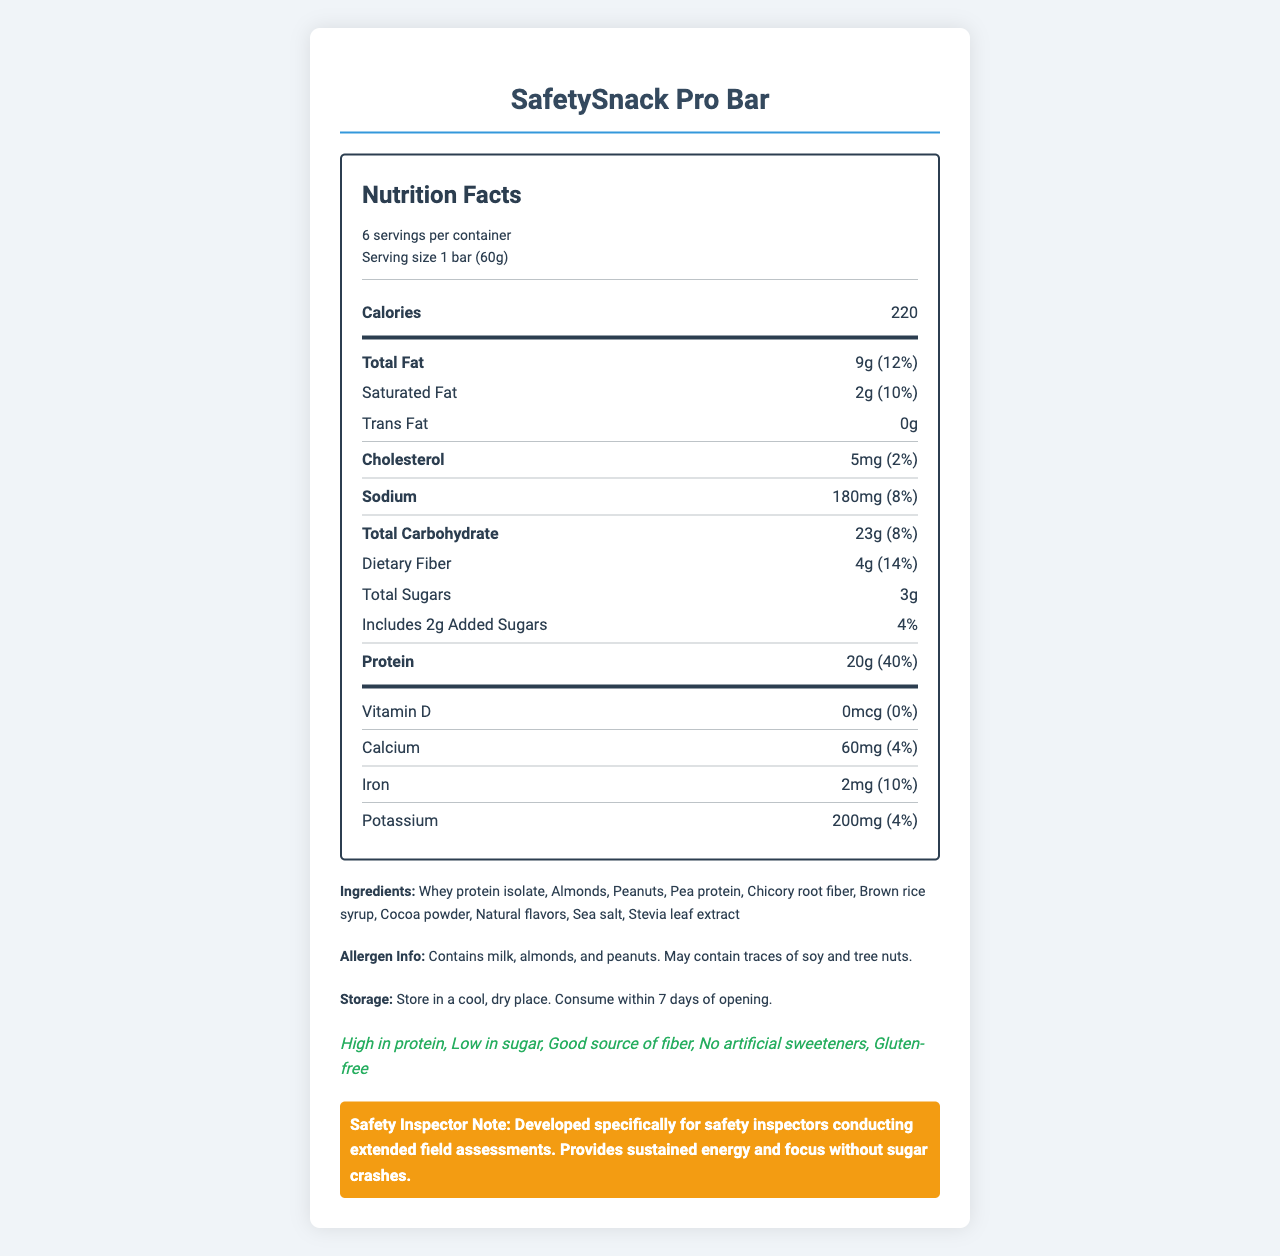what is the serving size of the SafetySnack Pro Bar? The document specifies the serving size in the serving information section as "1 bar (60g)".
Answer: 1 bar (60g) How many calories are in one serving of the SafetySnack Pro Bar? The document's nutrient row for calories indicates that one serving contains 220 calories.
Answer: 220 What is the amount of protein in one serving of the SafetySnack Pro Bar? The document lists the protein content as 20g per serving in the nutrient row for protein.
Answer: 20g What allergens are present in the SafetySnack Pro Bar? The document states under the allergen info section that the product contains milk, almonds, and peanuts.
Answer: Milk, almonds, and peanuts How should the SafetySnack Pro Bar be stored? The document specifies storage instructions under the storage section.
Answer: In a cool, dry place; consume within 7 days of opening How much dietary fiber does one serving of the SafetySnack Pro Bar contain? The nutrient row for dietary fiber indicates that one serving contains 4g of dietary fiber.
Answer: 4g Which of the following ingredients are included in the SafetySnack Pro Bar? A. Soy protein B. Almonds C. Raisins D. Honey The ingredients list includes almonds but not soy protein, raisins, or honey.
Answer: B What is the daily value percentage of iron in one serving? A. 4% B. 10% C. 14% D. 20% The document lists iron with a daily value percentage of 10%.
Answer: B Does the SafetySnack Pro Bar contain any artificial sweeteners? The document claims in the product claims section that it contains no artificial sweeteners.
Answer: No Summarize the main idea of the document. The document aims to inform users about the health benefits and ingredients of the SafetySnack Pro Bar, highlighting its suitability for safety inspectors requiring sustained energy and focus without sugar crashes.
Answer: The document provides detailed nutritional information about the SafetySnack Pro Bar, a high-protein, low-sugar snack designed for safety inspectors during extended field assessments. It includes nutritional content, ingredient list, allergen information, storage instructions, and product claims. What is the expiration date of the SafetySnack Pro Bar? The document does not provide any information regarding the expiration date of the product.
Answer: Not enough information 